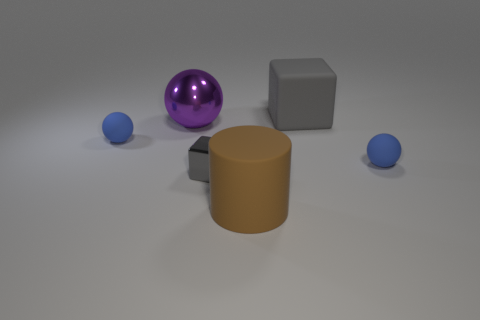Subtract all cyan balls. Subtract all red cylinders. How many balls are left? 3 Add 4 big brown matte cylinders. How many objects exist? 10 Subtract all cylinders. How many objects are left? 5 Add 6 small blue rubber spheres. How many small blue rubber spheres exist? 8 Subtract 0 red balls. How many objects are left? 6 Subtract all small shiny cubes. Subtract all small blue matte spheres. How many objects are left? 3 Add 5 big gray blocks. How many big gray blocks are left? 6 